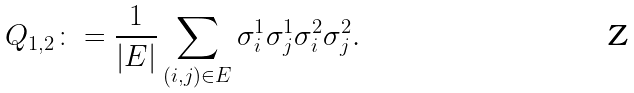Convert formula to latex. <formula><loc_0><loc_0><loc_500><loc_500>Q _ { 1 , 2 } \colon = \frac { 1 } { | E | } \sum _ { ( i , j ) \in E } \sigma _ { i } ^ { 1 } \sigma _ { j } ^ { 1 } \sigma _ { i } ^ { 2 } \sigma _ { j } ^ { 2 } .</formula> 